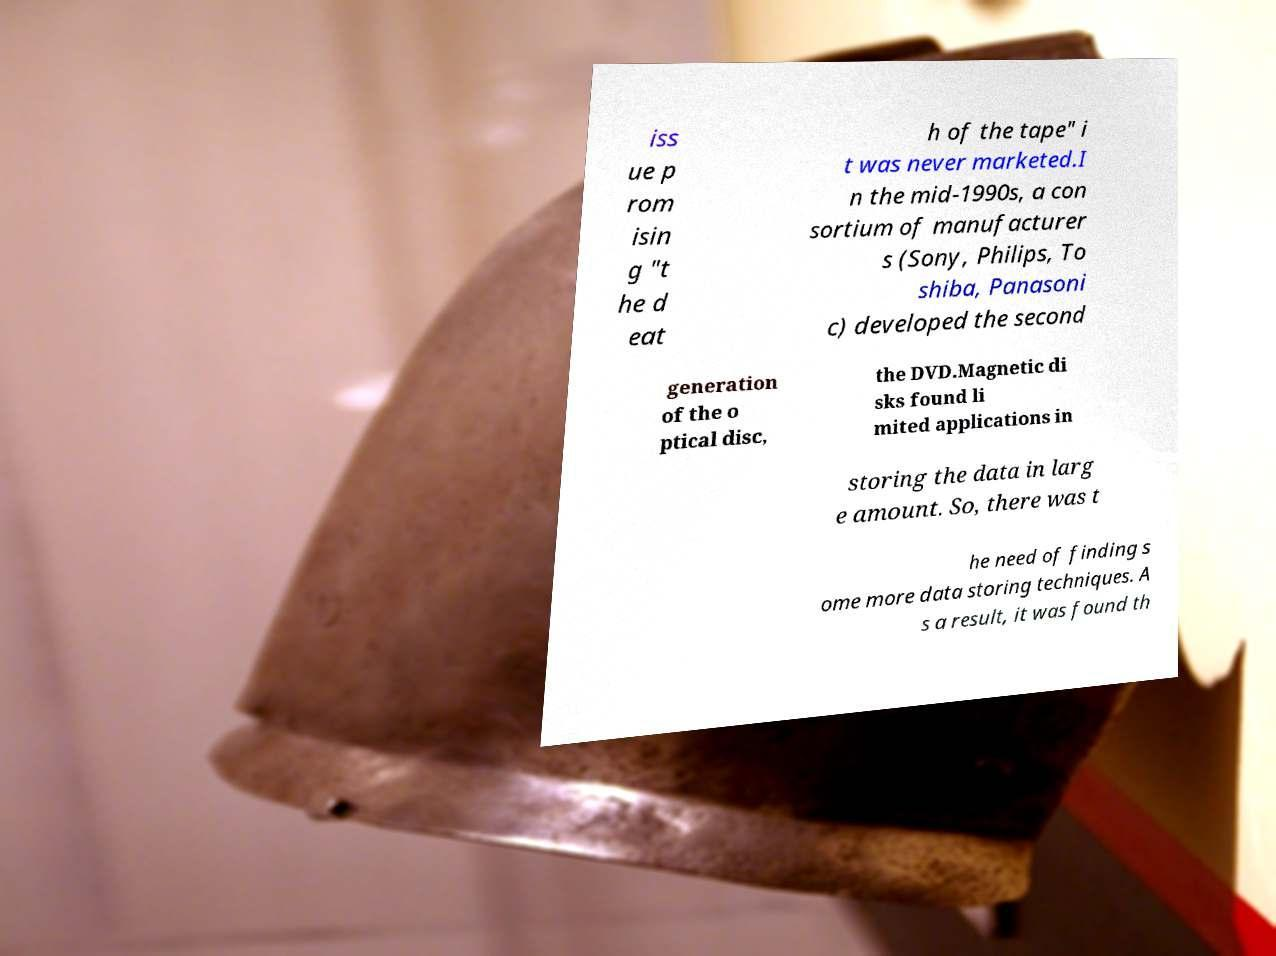I need the written content from this picture converted into text. Can you do that? iss ue p rom isin g "t he d eat h of the tape" i t was never marketed.I n the mid-1990s, a con sortium of manufacturer s (Sony, Philips, To shiba, Panasoni c) developed the second generation of the o ptical disc, the DVD.Magnetic di sks found li mited applications in storing the data in larg e amount. So, there was t he need of finding s ome more data storing techniques. A s a result, it was found th 